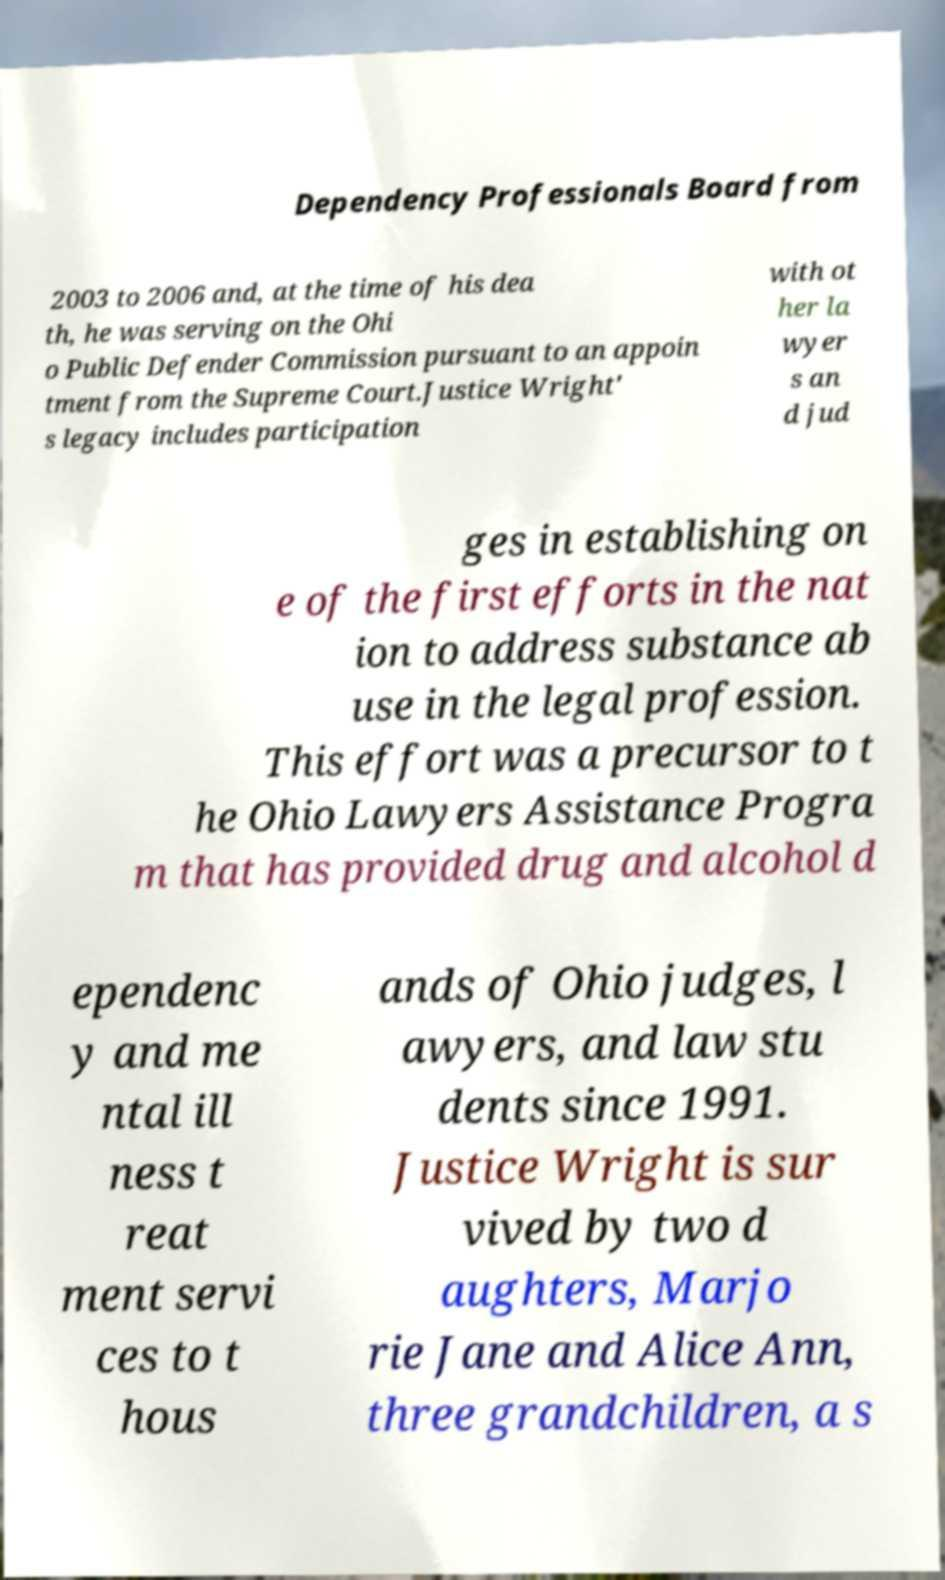There's text embedded in this image that I need extracted. Can you transcribe it verbatim? Dependency Professionals Board from 2003 to 2006 and, at the time of his dea th, he was serving on the Ohi o Public Defender Commission pursuant to an appoin tment from the Supreme Court.Justice Wright' s legacy includes participation with ot her la wyer s an d jud ges in establishing on e of the first efforts in the nat ion to address substance ab use in the legal profession. This effort was a precursor to t he Ohio Lawyers Assistance Progra m that has provided drug and alcohol d ependenc y and me ntal ill ness t reat ment servi ces to t hous ands of Ohio judges, l awyers, and law stu dents since 1991. Justice Wright is sur vived by two d aughters, Marjo rie Jane and Alice Ann, three grandchildren, a s 